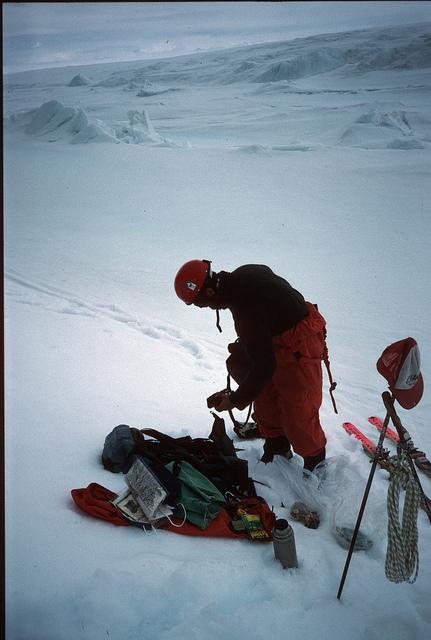What is this person wearing on their head?
Quick response, please. Helmet. Does this person need ice cream?
Write a very short answer. No. Where is the baseball cap?
Write a very short answer. On ski pole. 